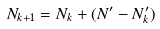<formula> <loc_0><loc_0><loc_500><loc_500>N _ { k + 1 } = N _ { k } + ( N ^ { \prime } - N ^ { \prime } _ { k } )</formula> 